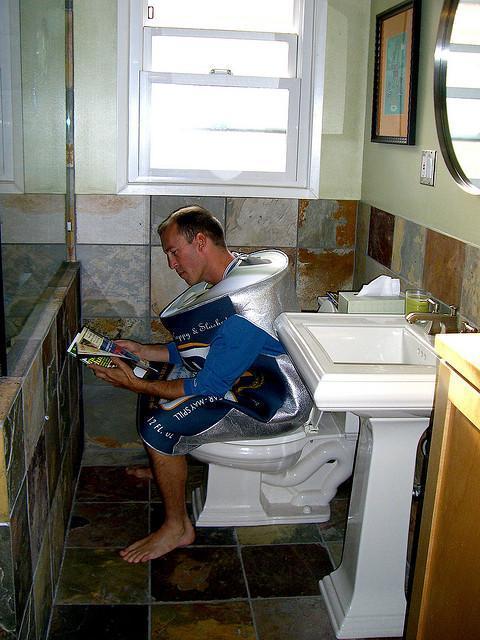How many people are there?
Give a very brief answer. 1. 